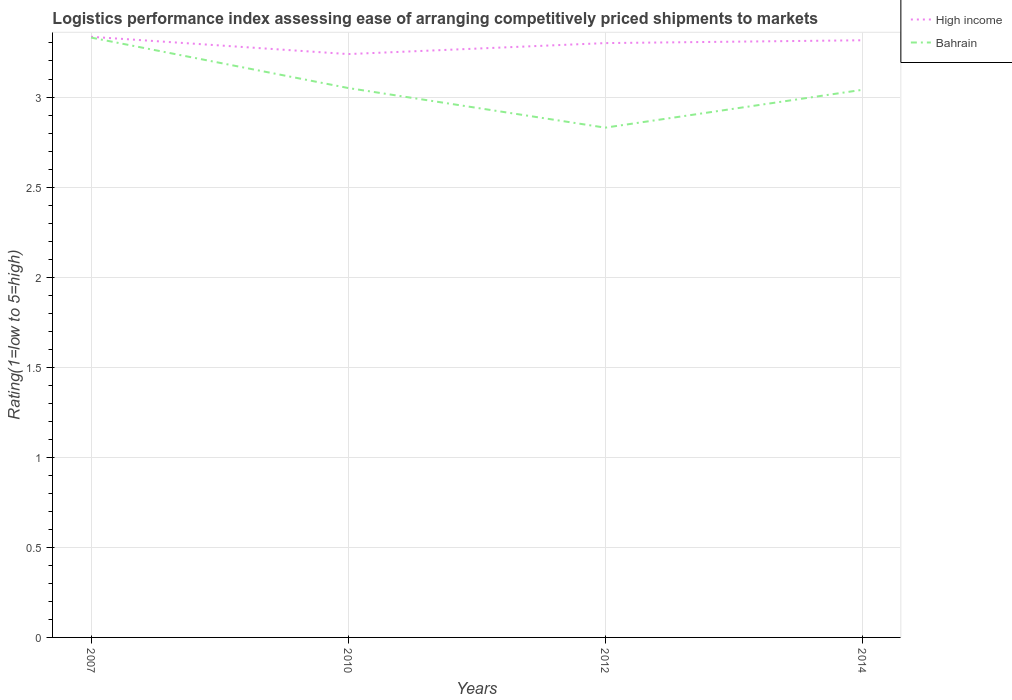Does the line corresponding to Bahrain intersect with the line corresponding to High income?
Your answer should be compact. No. Is the number of lines equal to the number of legend labels?
Your answer should be very brief. Yes. Across all years, what is the maximum Logistic performance index in Bahrain?
Your answer should be very brief. 2.83. What is the total Logistic performance index in High income in the graph?
Ensure brevity in your answer.  -0.06. What is the difference between the highest and the second highest Logistic performance index in Bahrain?
Your answer should be very brief. 0.5. Is the Logistic performance index in High income strictly greater than the Logistic performance index in Bahrain over the years?
Offer a terse response. No. Are the values on the major ticks of Y-axis written in scientific E-notation?
Your answer should be compact. No. Does the graph contain grids?
Offer a very short reply. Yes. Where does the legend appear in the graph?
Ensure brevity in your answer.  Top right. What is the title of the graph?
Provide a succinct answer. Logistics performance index assessing ease of arranging competitively priced shipments to markets. What is the label or title of the Y-axis?
Your answer should be compact. Rating(1=low to 5=high). What is the Rating(1=low to 5=high) of High income in 2007?
Provide a short and direct response. 3.33. What is the Rating(1=low to 5=high) of Bahrain in 2007?
Keep it short and to the point. 3.33. What is the Rating(1=low to 5=high) of High income in 2010?
Offer a very short reply. 3.24. What is the Rating(1=low to 5=high) of Bahrain in 2010?
Provide a short and direct response. 3.05. What is the Rating(1=low to 5=high) in High income in 2012?
Make the answer very short. 3.3. What is the Rating(1=low to 5=high) in Bahrain in 2012?
Keep it short and to the point. 2.83. What is the Rating(1=low to 5=high) of High income in 2014?
Your answer should be compact. 3.32. What is the Rating(1=low to 5=high) in Bahrain in 2014?
Give a very brief answer. 3.04. Across all years, what is the maximum Rating(1=low to 5=high) in High income?
Your answer should be very brief. 3.33. Across all years, what is the maximum Rating(1=low to 5=high) of Bahrain?
Make the answer very short. 3.33. Across all years, what is the minimum Rating(1=low to 5=high) of High income?
Keep it short and to the point. 3.24. Across all years, what is the minimum Rating(1=low to 5=high) in Bahrain?
Offer a terse response. 2.83. What is the total Rating(1=low to 5=high) in High income in the graph?
Offer a very short reply. 13.19. What is the total Rating(1=low to 5=high) of Bahrain in the graph?
Give a very brief answer. 12.25. What is the difference between the Rating(1=low to 5=high) in High income in 2007 and that in 2010?
Your response must be concise. 0.1. What is the difference between the Rating(1=low to 5=high) of Bahrain in 2007 and that in 2010?
Give a very brief answer. 0.28. What is the difference between the Rating(1=low to 5=high) of High income in 2007 and that in 2012?
Provide a succinct answer. 0.04. What is the difference between the Rating(1=low to 5=high) in High income in 2007 and that in 2014?
Provide a succinct answer. 0.02. What is the difference between the Rating(1=low to 5=high) in Bahrain in 2007 and that in 2014?
Your answer should be compact. 0.29. What is the difference between the Rating(1=low to 5=high) in High income in 2010 and that in 2012?
Ensure brevity in your answer.  -0.06. What is the difference between the Rating(1=low to 5=high) in Bahrain in 2010 and that in 2012?
Your response must be concise. 0.22. What is the difference between the Rating(1=low to 5=high) in High income in 2010 and that in 2014?
Keep it short and to the point. -0.08. What is the difference between the Rating(1=low to 5=high) in Bahrain in 2010 and that in 2014?
Give a very brief answer. 0.01. What is the difference between the Rating(1=low to 5=high) in High income in 2012 and that in 2014?
Provide a short and direct response. -0.02. What is the difference between the Rating(1=low to 5=high) in Bahrain in 2012 and that in 2014?
Your answer should be compact. -0.21. What is the difference between the Rating(1=low to 5=high) in High income in 2007 and the Rating(1=low to 5=high) in Bahrain in 2010?
Keep it short and to the point. 0.28. What is the difference between the Rating(1=low to 5=high) in High income in 2007 and the Rating(1=low to 5=high) in Bahrain in 2012?
Keep it short and to the point. 0.5. What is the difference between the Rating(1=low to 5=high) in High income in 2007 and the Rating(1=low to 5=high) in Bahrain in 2014?
Give a very brief answer. 0.29. What is the difference between the Rating(1=low to 5=high) of High income in 2010 and the Rating(1=low to 5=high) of Bahrain in 2012?
Make the answer very short. 0.41. What is the difference between the Rating(1=low to 5=high) of High income in 2010 and the Rating(1=low to 5=high) of Bahrain in 2014?
Keep it short and to the point. 0.2. What is the difference between the Rating(1=low to 5=high) of High income in 2012 and the Rating(1=low to 5=high) of Bahrain in 2014?
Your answer should be compact. 0.26. What is the average Rating(1=low to 5=high) of High income per year?
Offer a very short reply. 3.3. What is the average Rating(1=low to 5=high) of Bahrain per year?
Ensure brevity in your answer.  3.06. In the year 2007, what is the difference between the Rating(1=low to 5=high) in High income and Rating(1=low to 5=high) in Bahrain?
Offer a terse response. 0. In the year 2010, what is the difference between the Rating(1=low to 5=high) in High income and Rating(1=low to 5=high) in Bahrain?
Provide a succinct answer. 0.19. In the year 2012, what is the difference between the Rating(1=low to 5=high) of High income and Rating(1=low to 5=high) of Bahrain?
Your answer should be very brief. 0.47. In the year 2014, what is the difference between the Rating(1=low to 5=high) in High income and Rating(1=low to 5=high) in Bahrain?
Offer a terse response. 0.28. What is the ratio of the Rating(1=low to 5=high) in High income in 2007 to that in 2010?
Provide a short and direct response. 1.03. What is the ratio of the Rating(1=low to 5=high) of Bahrain in 2007 to that in 2010?
Your answer should be compact. 1.09. What is the ratio of the Rating(1=low to 5=high) of High income in 2007 to that in 2012?
Give a very brief answer. 1.01. What is the ratio of the Rating(1=low to 5=high) of Bahrain in 2007 to that in 2012?
Make the answer very short. 1.18. What is the ratio of the Rating(1=low to 5=high) in Bahrain in 2007 to that in 2014?
Ensure brevity in your answer.  1.1. What is the ratio of the Rating(1=low to 5=high) in High income in 2010 to that in 2012?
Ensure brevity in your answer.  0.98. What is the ratio of the Rating(1=low to 5=high) of Bahrain in 2010 to that in 2012?
Make the answer very short. 1.08. What is the ratio of the Rating(1=low to 5=high) of High income in 2010 to that in 2014?
Your answer should be compact. 0.98. What is the ratio of the Rating(1=low to 5=high) in High income in 2012 to that in 2014?
Keep it short and to the point. 1. What is the ratio of the Rating(1=low to 5=high) in Bahrain in 2012 to that in 2014?
Ensure brevity in your answer.  0.93. What is the difference between the highest and the second highest Rating(1=low to 5=high) of High income?
Offer a terse response. 0.02. What is the difference between the highest and the second highest Rating(1=low to 5=high) of Bahrain?
Provide a short and direct response. 0.28. What is the difference between the highest and the lowest Rating(1=low to 5=high) of High income?
Your response must be concise. 0.1. 